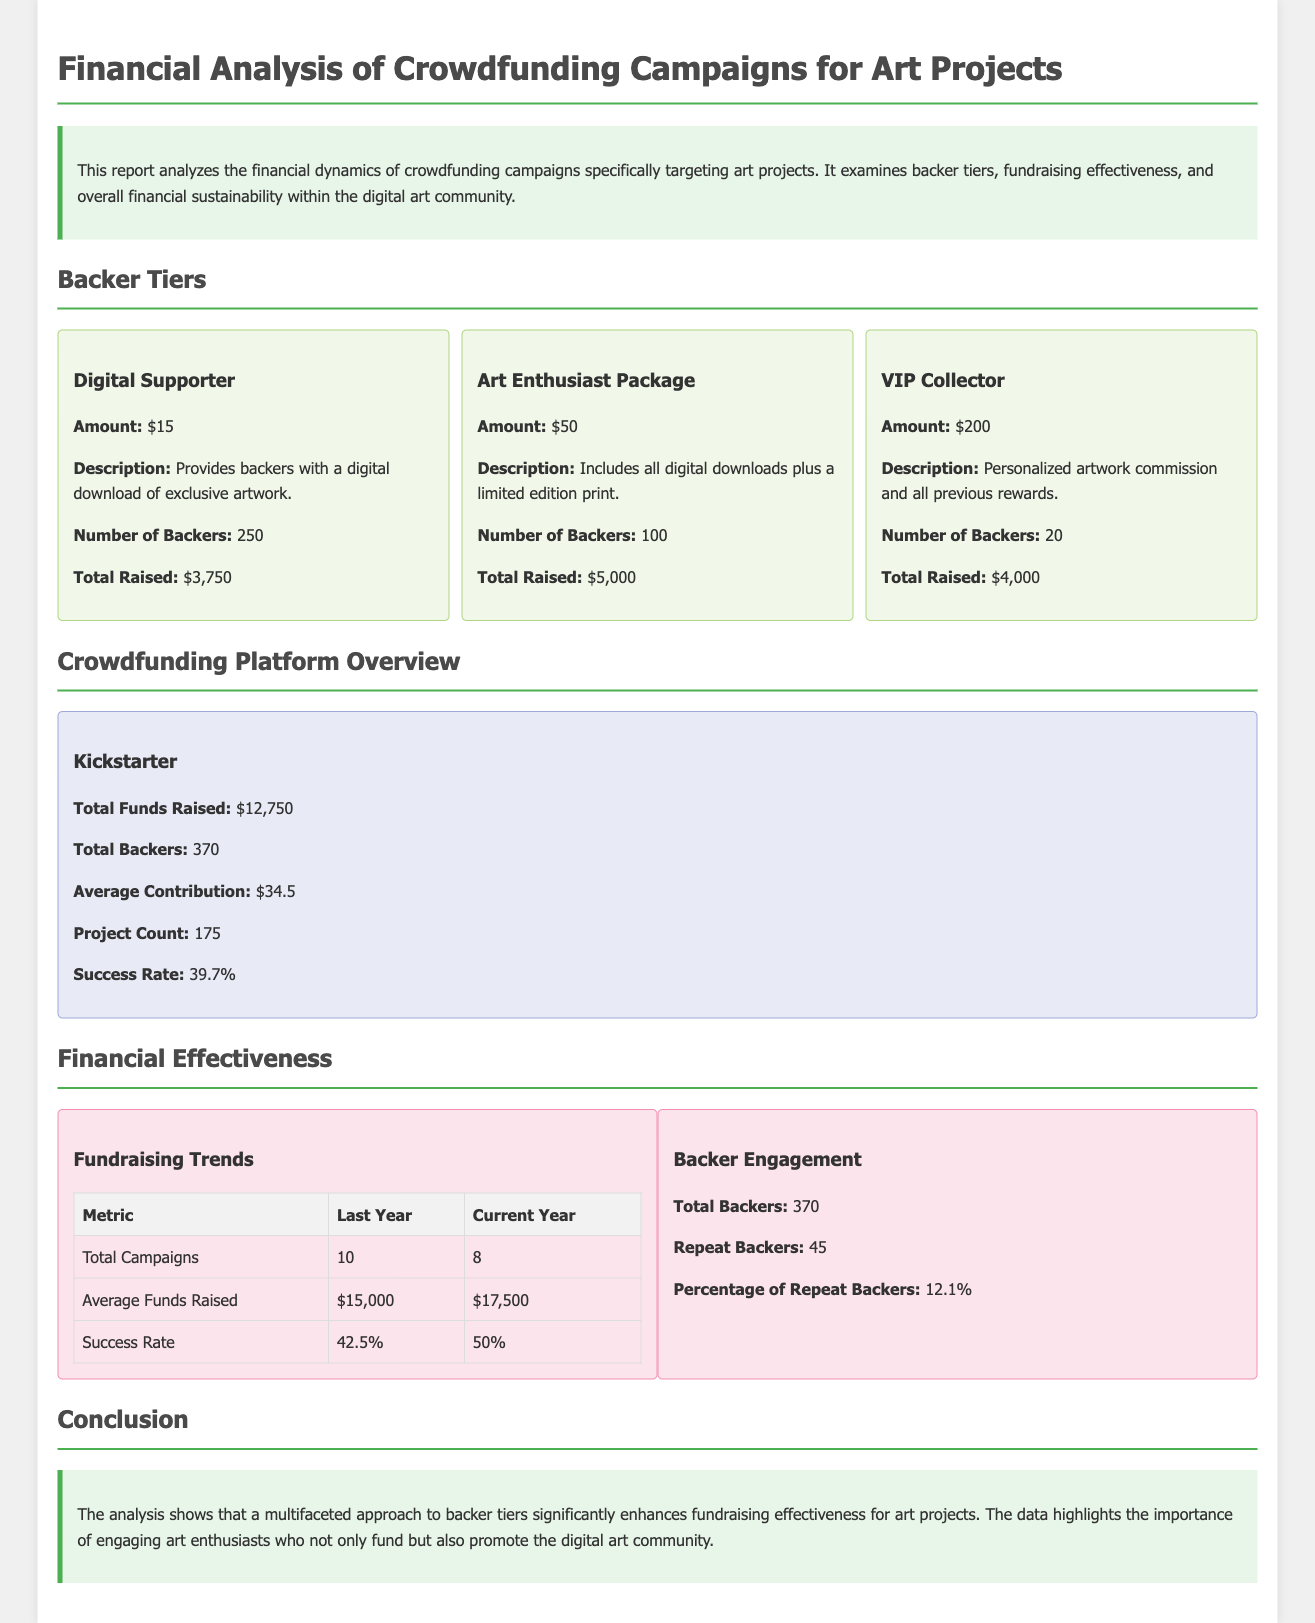What is the total amount raised by the Digital Supporter tier? The total raised by the Digital Supporter tier is directly mentioned in the document as $3,750.
Answer: $3,750 What is the average contribution on Kickstarter? The average contribution is specified in the crowdfunding platform overview as $34.5.
Answer: $34.5 How many total backers participated in the campaigns? The total number of backers is listed as 370 in the crowdfunding platform overview.
Answer: 370 What is the success rate of crowdfunding campaigns this year? The current success rate mentioned in the financial effectiveness section is 50%.
Answer: 50% Which backer tier has the highest number of backers? The Digital Supporter tier has the highest number of backers at 250.
Answer: Digital Supporter What was the total funds raised last year? The average funds raised last year is noted as $15,000; hence, the total raised can be inferred from previous remarks about campaigns.
Answer: $15,000 What percentage of backers are repeat backers? The document specifies that the percentage of repeat backers is 12.1%.
Answer: 12.1% What is the number of art projects on Kickstarter? The document states that the project count on Kickstarter is 175.
Answer: 175 What is highlighted as important for engaging backers? The analysis emphasizes the importance of engaging art enthusiasts.
Answer: Engaging art enthusiasts 